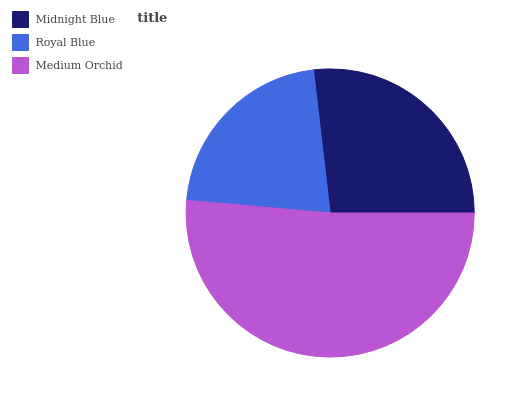Is Royal Blue the minimum?
Answer yes or no. Yes. Is Medium Orchid the maximum?
Answer yes or no. Yes. Is Medium Orchid the minimum?
Answer yes or no. No. Is Royal Blue the maximum?
Answer yes or no. No. Is Medium Orchid greater than Royal Blue?
Answer yes or no. Yes. Is Royal Blue less than Medium Orchid?
Answer yes or no. Yes. Is Royal Blue greater than Medium Orchid?
Answer yes or no. No. Is Medium Orchid less than Royal Blue?
Answer yes or no. No. Is Midnight Blue the high median?
Answer yes or no. Yes. Is Midnight Blue the low median?
Answer yes or no. Yes. Is Medium Orchid the high median?
Answer yes or no. No. Is Medium Orchid the low median?
Answer yes or no. No. 